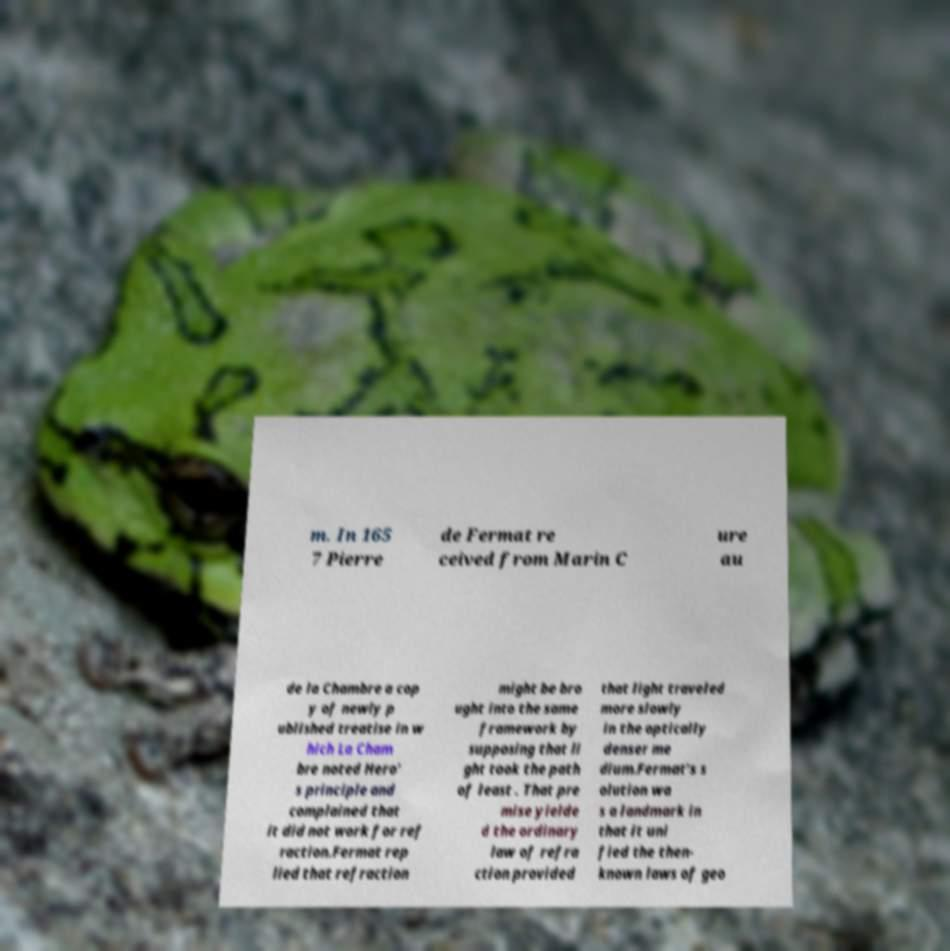Can you accurately transcribe the text from the provided image for me? m. In 165 7 Pierre de Fermat re ceived from Marin C ure au de la Chambre a cop y of newly p ublished treatise in w hich La Cham bre noted Hero' s principle and complained that it did not work for ref raction.Fermat rep lied that refraction might be bro ught into the same framework by supposing that li ght took the path of least . That pre mise yielde d the ordinary law of refra ction provided that light traveled more slowly in the optically denser me dium.Fermat's s olution wa s a landmark in that it uni fied the then- known laws of geo 